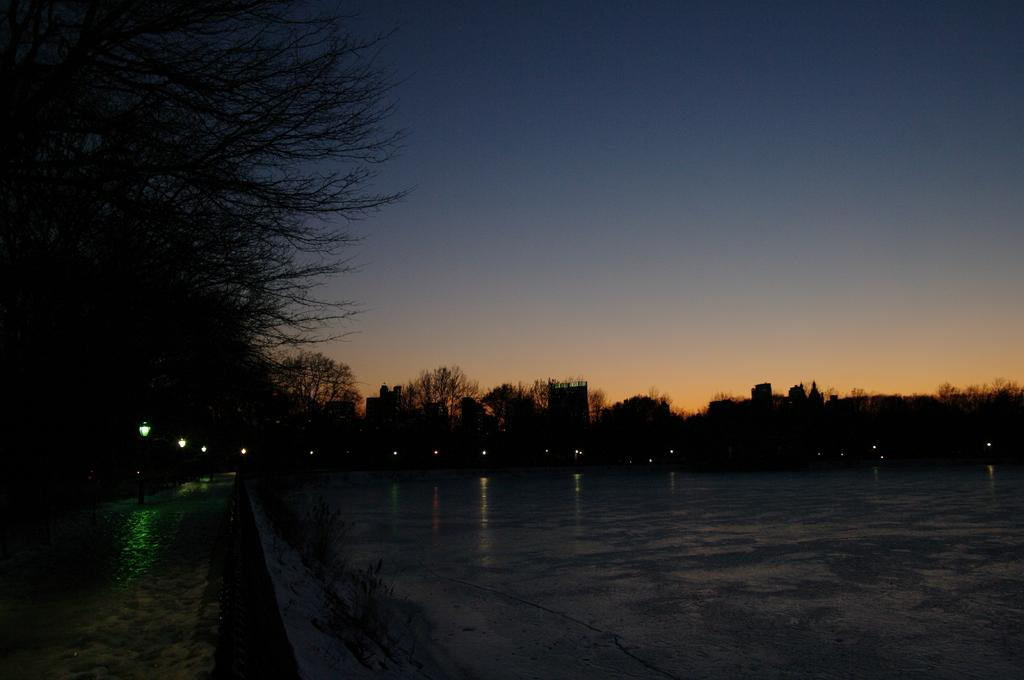What is the overall lighting condition in the image? The image is dark. What can be seen on the left side of the image? There are trees on the left side of the image. What is visible at the top of the image? The sky is visible at the top of the image. What type of star can be seen singing a song in the image? There is no star or song present in the image; it features a dark scene with trees and the sky. 